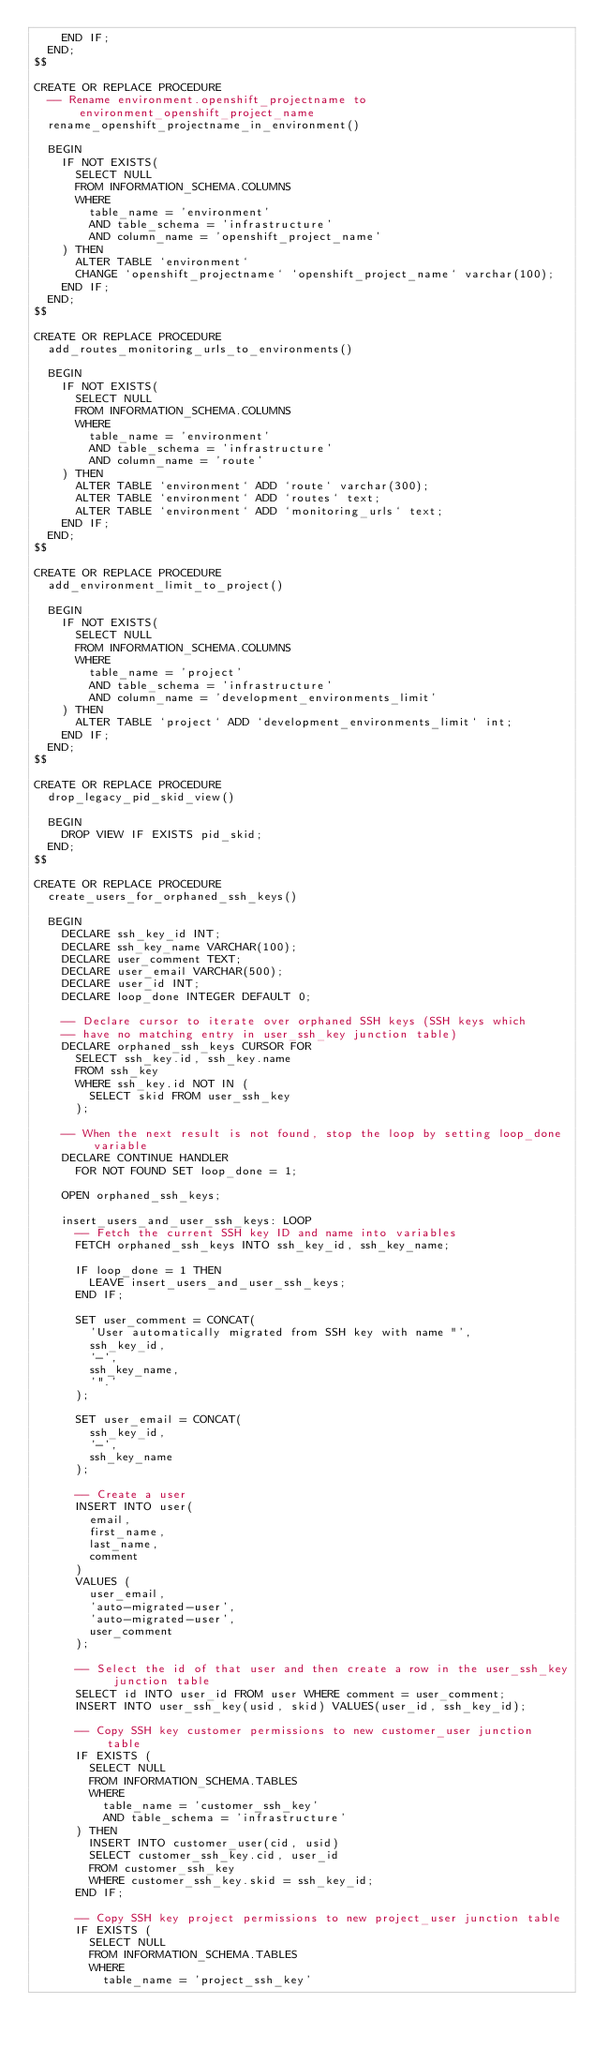Convert code to text. <code><loc_0><loc_0><loc_500><loc_500><_SQL_>    END IF;
  END;
$$

CREATE OR REPLACE PROCEDURE
  -- Rename environment.openshift_projectname to environment_openshift_project_name
  rename_openshift_projectname_in_environment()

  BEGIN
    IF NOT EXISTS(
      SELECT NULL
      FROM INFORMATION_SCHEMA.COLUMNS
      WHERE
        table_name = 'environment'
        AND table_schema = 'infrastructure'
        AND column_name = 'openshift_project_name'
    ) THEN
      ALTER TABLE `environment`
      CHANGE `openshift_projectname` `openshift_project_name` varchar(100);
    END IF;
  END;
$$

CREATE OR REPLACE PROCEDURE
  add_routes_monitoring_urls_to_environments()

  BEGIN
    IF NOT EXISTS(
      SELECT NULL
      FROM INFORMATION_SCHEMA.COLUMNS
      WHERE
        table_name = 'environment'
        AND table_schema = 'infrastructure'
        AND column_name = 'route'
    ) THEN
      ALTER TABLE `environment` ADD `route` varchar(300);
      ALTER TABLE `environment` ADD `routes` text;
      ALTER TABLE `environment` ADD `monitoring_urls` text;
    END IF;
  END;
$$

CREATE OR REPLACE PROCEDURE
  add_environment_limit_to_project()

  BEGIN
    IF NOT EXISTS(
      SELECT NULL
      FROM INFORMATION_SCHEMA.COLUMNS
      WHERE
        table_name = 'project'
        AND table_schema = 'infrastructure'
        AND column_name = 'development_environments_limit'
    ) THEN
      ALTER TABLE `project` ADD `development_environments_limit` int;
    END IF;
  END;
$$

CREATE OR REPLACE PROCEDURE
  drop_legacy_pid_skid_view()

  BEGIN
    DROP VIEW IF EXISTS pid_skid;
  END;
$$

CREATE OR REPLACE PROCEDURE
  create_users_for_orphaned_ssh_keys()

  BEGIN
    DECLARE ssh_key_id INT;
    DECLARE ssh_key_name VARCHAR(100);
    DECLARE user_comment TEXT;
    DECLARE user_email VARCHAR(500);
    DECLARE user_id INT;
    DECLARE loop_done INTEGER DEFAULT 0;

    -- Declare cursor to iterate over orphaned SSH keys (SSH keys which
    -- have no matching entry in user_ssh_key junction table)
    DECLARE orphaned_ssh_keys CURSOR FOR
      SELECT ssh_key.id, ssh_key.name
      FROM ssh_key
      WHERE ssh_key.id NOT IN (
        SELECT skid FROM user_ssh_key
      );

    -- When the next result is not found, stop the loop by setting loop_done variable
    DECLARE CONTINUE HANDLER
      FOR NOT FOUND SET loop_done = 1;

    OPEN orphaned_ssh_keys;

    insert_users_and_user_ssh_keys: LOOP
      -- Fetch the current SSH key ID and name into variables
      FETCH orphaned_ssh_keys INTO ssh_key_id, ssh_key_name;

      IF loop_done = 1 THEN
        LEAVE insert_users_and_user_ssh_keys;
      END IF;

      SET user_comment = CONCAT(
        'User automatically migrated from SSH key with name "',
        ssh_key_id,
        '-',
        ssh_key_name,
        '".'
      );

      SET user_email = CONCAT(
        ssh_key_id,
        '-',
        ssh_key_name
      );

      -- Create a user
      INSERT INTO user(
        email,
        first_name,
        last_name,
        comment
      )
      VALUES (
        user_email,
        'auto-migrated-user',
        'auto-migrated-user',
        user_comment
      );

      -- Select the id of that user and then create a row in the user_ssh_key junction table
      SELECT id INTO user_id FROM user WHERE comment = user_comment;
      INSERT INTO user_ssh_key(usid, skid) VALUES(user_id, ssh_key_id);

      -- Copy SSH key customer permissions to new customer_user junction table
      IF EXISTS (
        SELECT NULL
        FROM INFORMATION_SCHEMA.TABLES
        WHERE
          table_name = 'customer_ssh_key'
          AND table_schema = 'infrastructure'
      ) THEN
        INSERT INTO customer_user(cid, usid)
        SELECT customer_ssh_key.cid, user_id
        FROM customer_ssh_key
        WHERE customer_ssh_key.skid = ssh_key_id;
      END IF;

      -- Copy SSH key project permissions to new project_user junction table
      IF EXISTS (
        SELECT NULL
        FROM INFORMATION_SCHEMA.TABLES
        WHERE
          table_name = 'project_ssh_key'</code> 